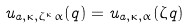Convert formula to latex. <formula><loc_0><loc_0><loc_500><loc_500>u _ { a , \kappa , \zeta ^ { \kappa } \alpha } ( q ) = u _ { a , \kappa , \alpha } ( \zeta q )</formula> 